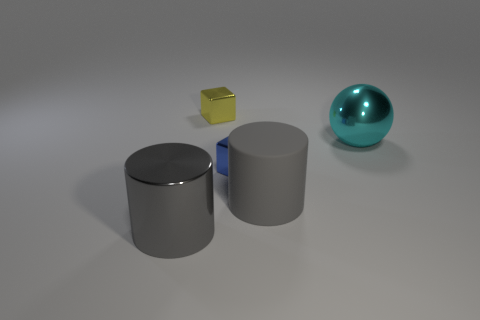There is a yellow object that is behind the cylinder that is to the left of the block that is behind the small blue cube; what is its size?
Make the answer very short. Small. There is a shiny block in front of the cyan shiny object; what is its size?
Offer a very short reply. Small. What number of things are either metallic cylinders or gray cylinders behind the big gray metallic cylinder?
Give a very brief answer. 2. What number of other objects are there of the same size as the blue thing?
Provide a short and direct response. 1. There is another large object that is the same shape as the large gray metallic object; what is its material?
Give a very brief answer. Rubber. Is the number of metal objects to the left of the sphere greater than the number of red rubber balls?
Give a very brief answer. Yes. Is there anything else that has the same color as the sphere?
Give a very brief answer. No. There is a yellow object that is the same material as the small blue thing; what shape is it?
Offer a very short reply. Cube. Does the big gray thing on the right side of the blue object have the same material as the blue object?
Make the answer very short. No. There is a large thing that is the same color as the rubber cylinder; what is its shape?
Give a very brief answer. Cylinder. 